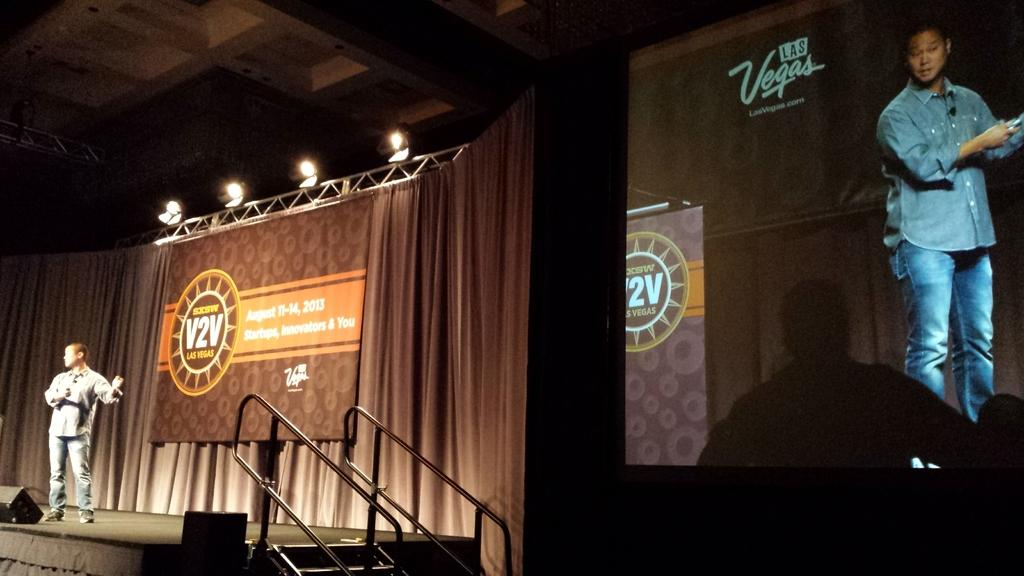What is the man in the image doing? The man is standing on a stage. What can be seen on the stage? The stage has lights. What is on the right side of the image? There is a screen on the right side of the image. What is displayed on the screen? The screen is showing the man on the stage. What type of corn is growing on the stage in the image? There is no corn present in the image; it features a man standing on a stage with lights and a screen displaying him. Can you see a scarecrow standing next to the man on the stage? There is no scarecrow present in the image; it only features the man standing on the stage with lights and a screen displaying him. 